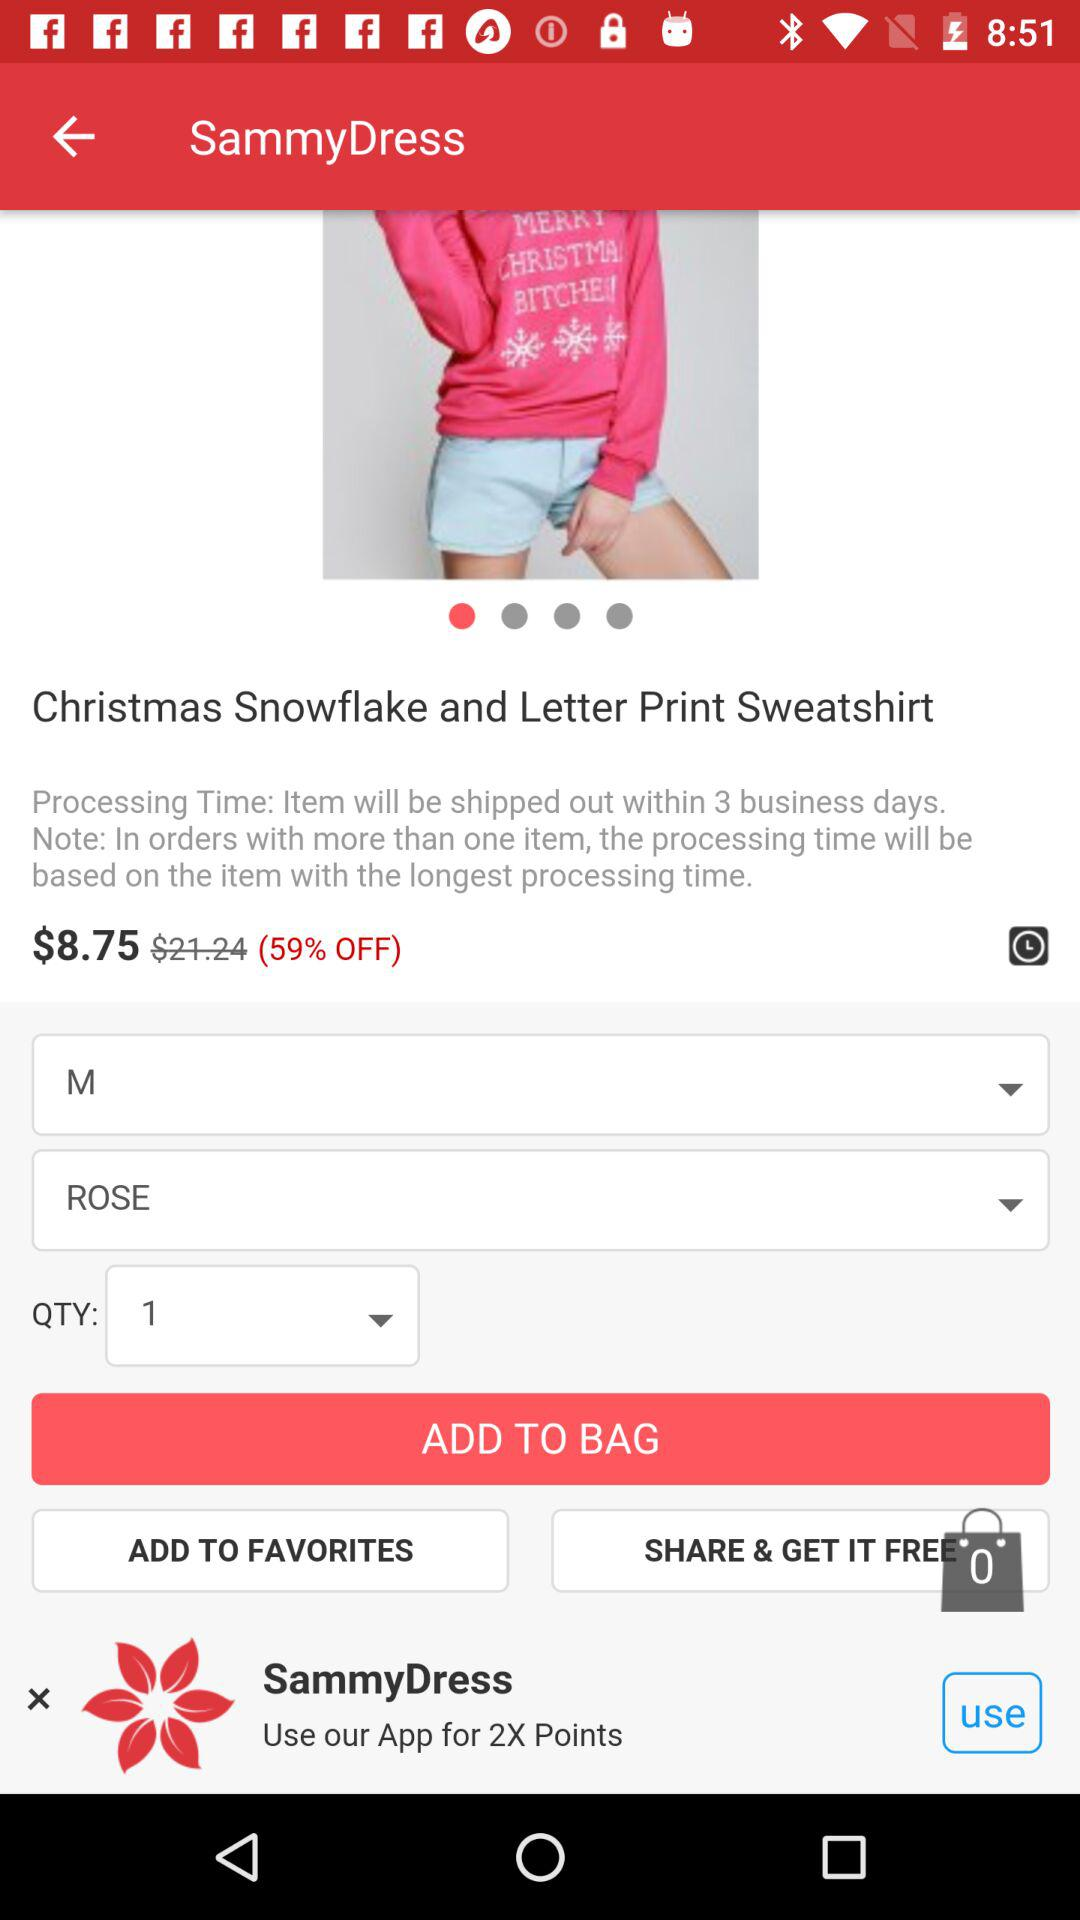How many items are there in the shopping bag? There are 0 items in the shopping bag. 